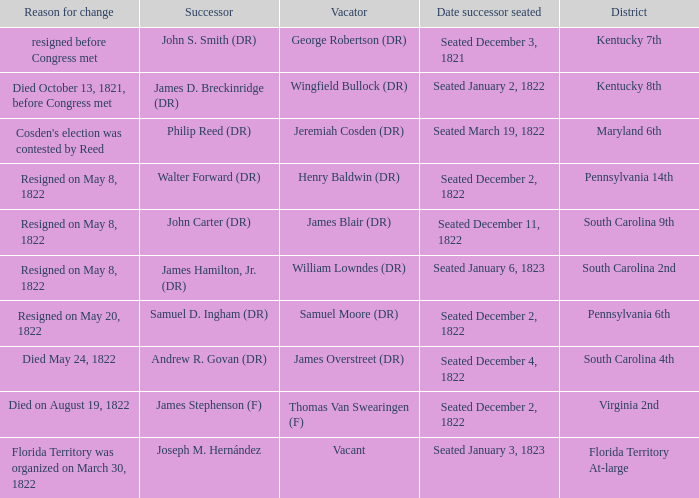Who is the person relinquishing when south carolina 4th is the district? James Overstreet (DR). 